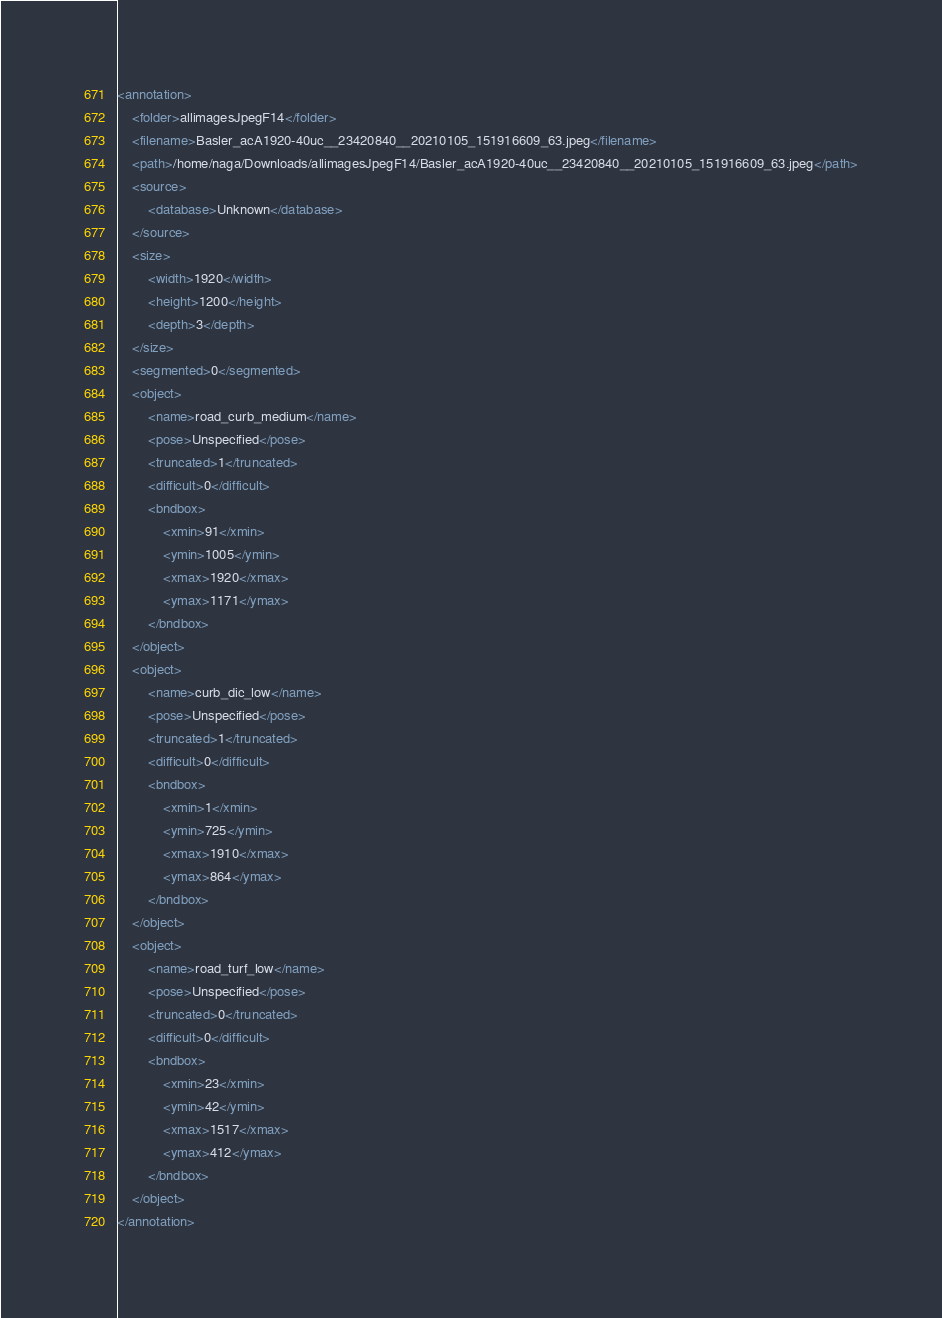Convert code to text. <code><loc_0><loc_0><loc_500><loc_500><_XML_><annotation>
	<folder>allimagesJpegF14</folder>
	<filename>Basler_acA1920-40uc__23420840__20210105_151916609_63.jpeg</filename>
	<path>/home/naga/Downloads/allimagesJpegF14/Basler_acA1920-40uc__23420840__20210105_151916609_63.jpeg</path>
	<source>
		<database>Unknown</database>
	</source>
	<size>
		<width>1920</width>
		<height>1200</height>
		<depth>3</depth>
	</size>
	<segmented>0</segmented>
	<object>
		<name>road_curb_medium</name>
		<pose>Unspecified</pose>
		<truncated>1</truncated>
		<difficult>0</difficult>
		<bndbox>
			<xmin>91</xmin>
			<ymin>1005</ymin>
			<xmax>1920</xmax>
			<ymax>1171</ymax>
		</bndbox>
	</object>
	<object>
		<name>curb_dic_low</name>
		<pose>Unspecified</pose>
		<truncated>1</truncated>
		<difficult>0</difficult>
		<bndbox>
			<xmin>1</xmin>
			<ymin>725</ymin>
			<xmax>1910</xmax>
			<ymax>864</ymax>
		</bndbox>
	</object>
	<object>
		<name>road_turf_low</name>
		<pose>Unspecified</pose>
		<truncated>0</truncated>
		<difficult>0</difficult>
		<bndbox>
			<xmin>23</xmin>
			<ymin>42</ymin>
			<xmax>1517</xmax>
			<ymax>412</ymax>
		</bndbox>
	</object>
</annotation>
</code> 